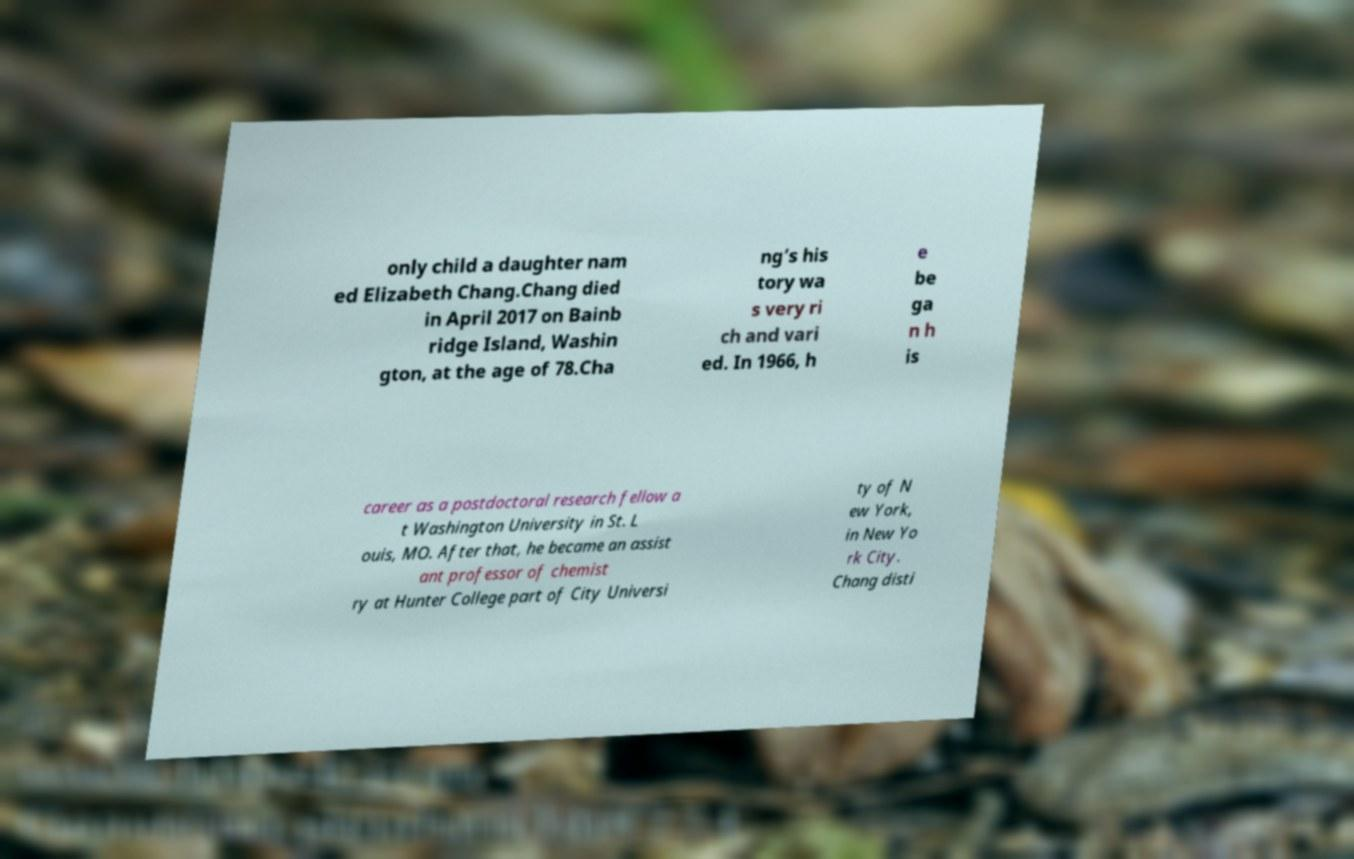Could you assist in decoding the text presented in this image and type it out clearly? only child a daughter nam ed Elizabeth Chang.Chang died in April 2017 on Bainb ridge Island, Washin gton, at the age of 78.Cha ng’s his tory wa s very ri ch and vari ed. In 1966, h e be ga n h is career as a postdoctoral research fellow a t Washington University in St. L ouis, MO. After that, he became an assist ant professor of chemist ry at Hunter College part of City Universi ty of N ew York, in New Yo rk City. Chang disti 